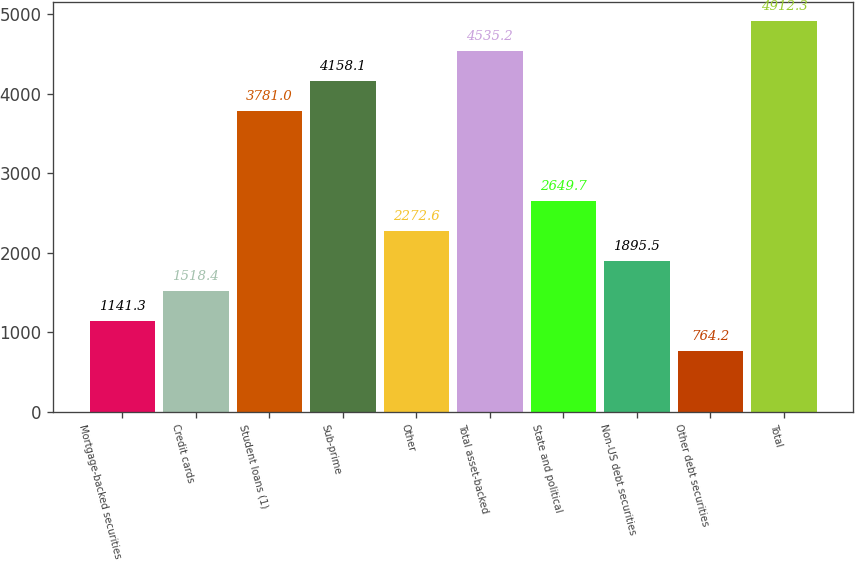<chart> <loc_0><loc_0><loc_500><loc_500><bar_chart><fcel>Mortgage-backed securities<fcel>Credit cards<fcel>Student loans (1)<fcel>Sub-prime<fcel>Other<fcel>Total asset-backed<fcel>State and political<fcel>Non-US debt securities<fcel>Other debt securities<fcel>Total<nl><fcel>1141.3<fcel>1518.4<fcel>3781<fcel>4158.1<fcel>2272.6<fcel>4535.2<fcel>2649.7<fcel>1895.5<fcel>764.2<fcel>4912.3<nl></chart> 